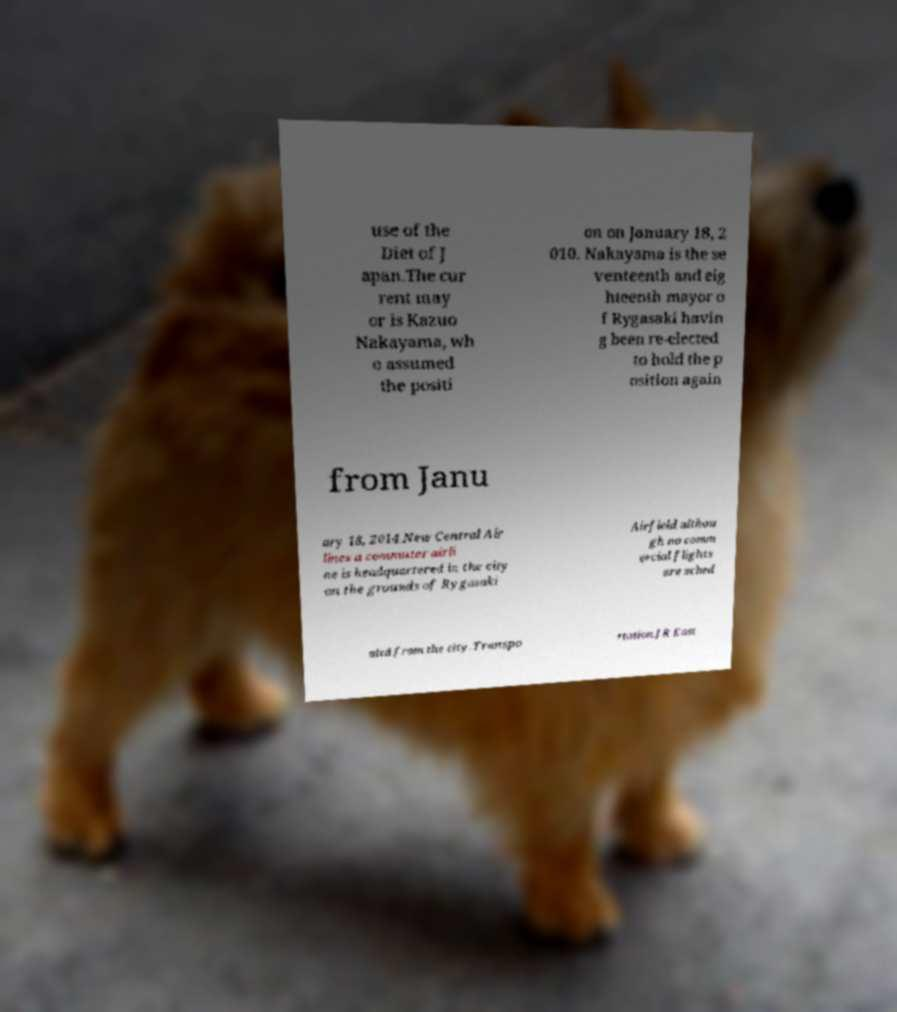There's text embedded in this image that I need extracted. Can you transcribe it verbatim? use of the Diet of J apan.The cur rent may or is Kazuo Nakayama, wh o assumed the positi on on January 18, 2 010. Nakayama is the se venteenth and eig hteenth mayor o f Rygasaki havin g been re-elected to hold the p osition again from Janu ary 18, 2014.New Central Air lines a commuter airli ne is headquartered in the city on the grounds of Rygasaki Airfield althou gh no comm ercial flights are sched uled from the city.Transpo rtation.JR East 